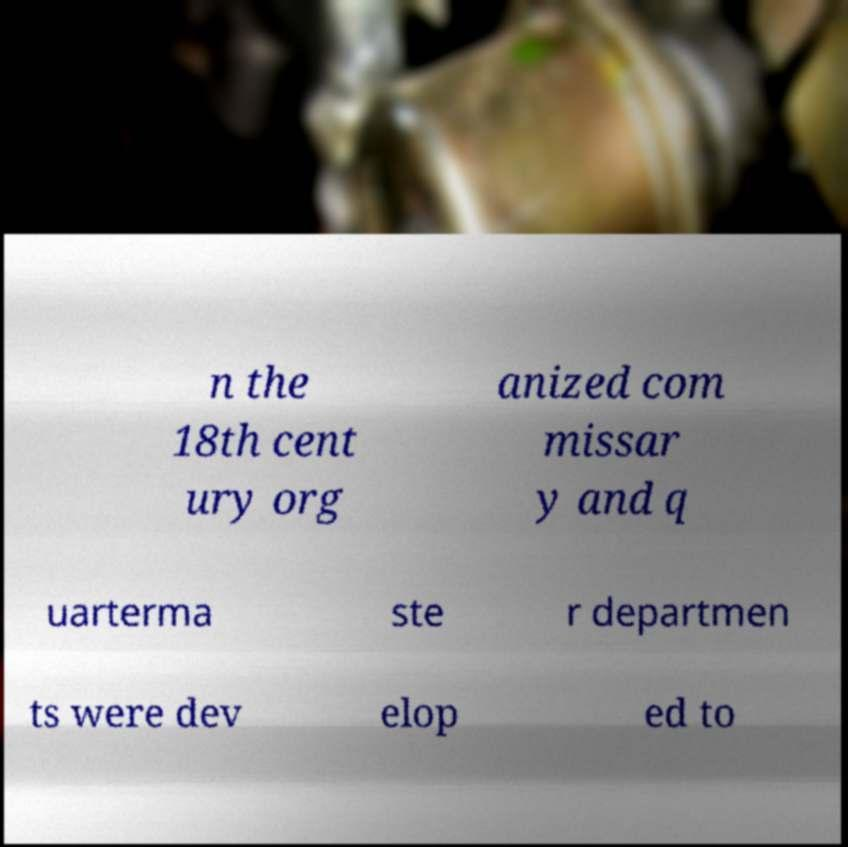Can you accurately transcribe the text from the provided image for me? n the 18th cent ury org anized com missar y and q uarterma ste r departmen ts were dev elop ed to 